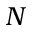<formula> <loc_0><loc_0><loc_500><loc_500>N</formula> 